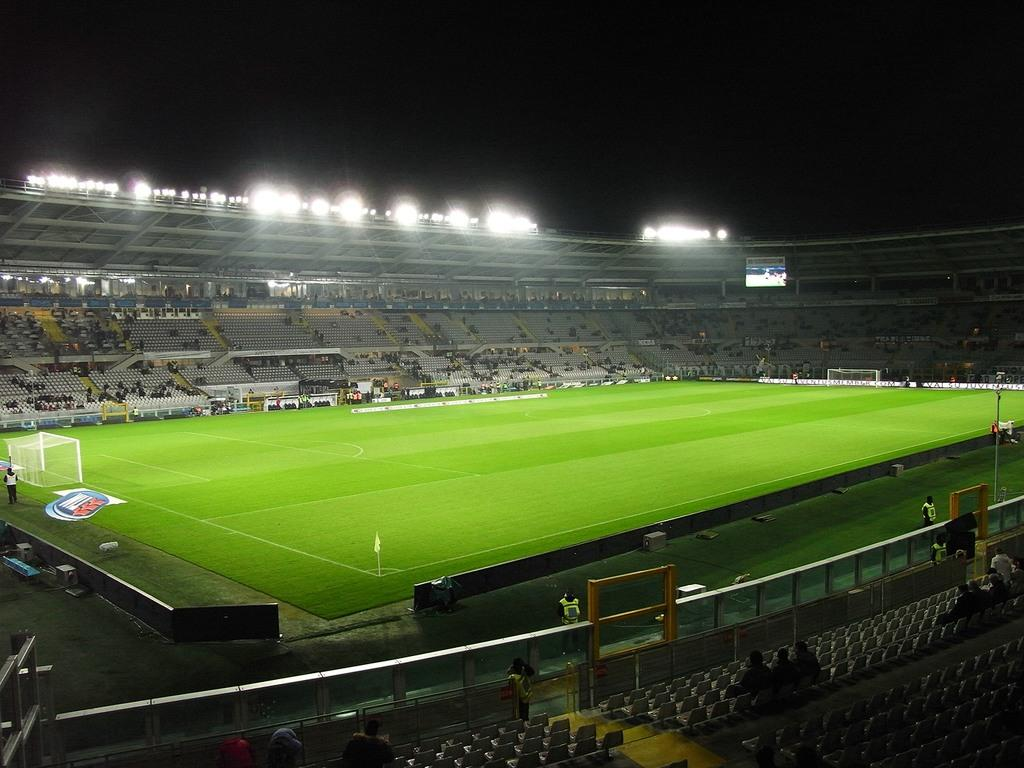What type of venue is depicted in the image? There is a football ground in the image. What can be seen on the football ground? Chairs are present on the football ground. What is visible at the top of the image? There are lights on the top of the image. Where was the image taken? The image was taken in a football stadium. What is the condition of the sky in the image? The sky is dark in the image. What type of produce is being sold by the beggar in the image? There is no beggar or produce present in the image; it depicts a football ground with chairs and lights. Can you see a kite flying in the image? There is no kite visible in the image; it shows a football ground with chairs and lights. 